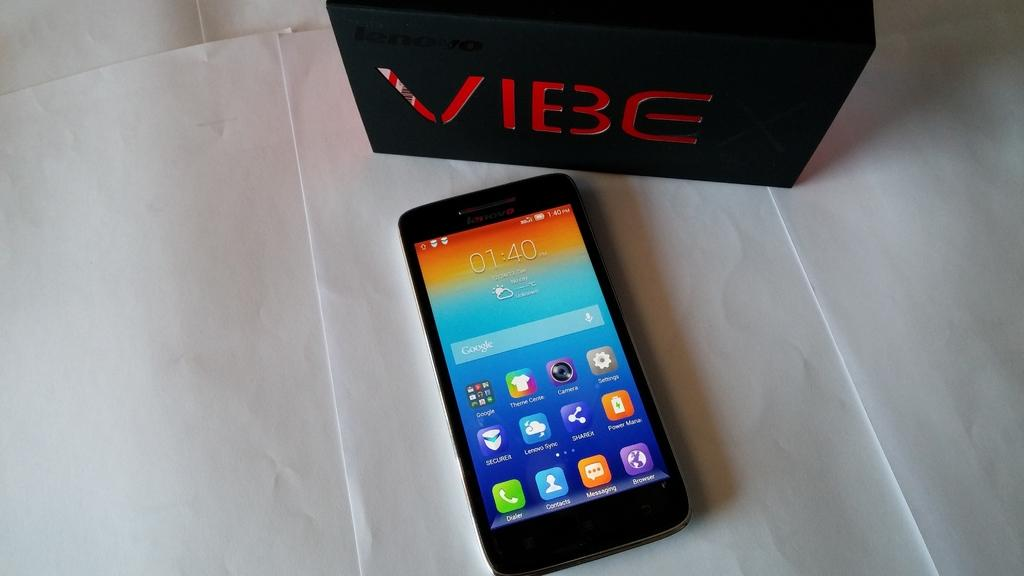Where was the image taken? The image was taken indoors. What is located at the bottom of the image? There is a table at the bottom of the image. What items can be seen on the table? There are papers, a mobile, and a box on the table. How many wings are visible on the box in the image? There are no wings visible on the box in the image, as it is a regular box without any wings. 